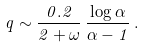Convert formula to latex. <formula><loc_0><loc_0><loc_500><loc_500>q \sim \frac { 0 . 2 } { 2 + \omega } \, \frac { \log \alpha } { \alpha - 1 } \, .</formula> 